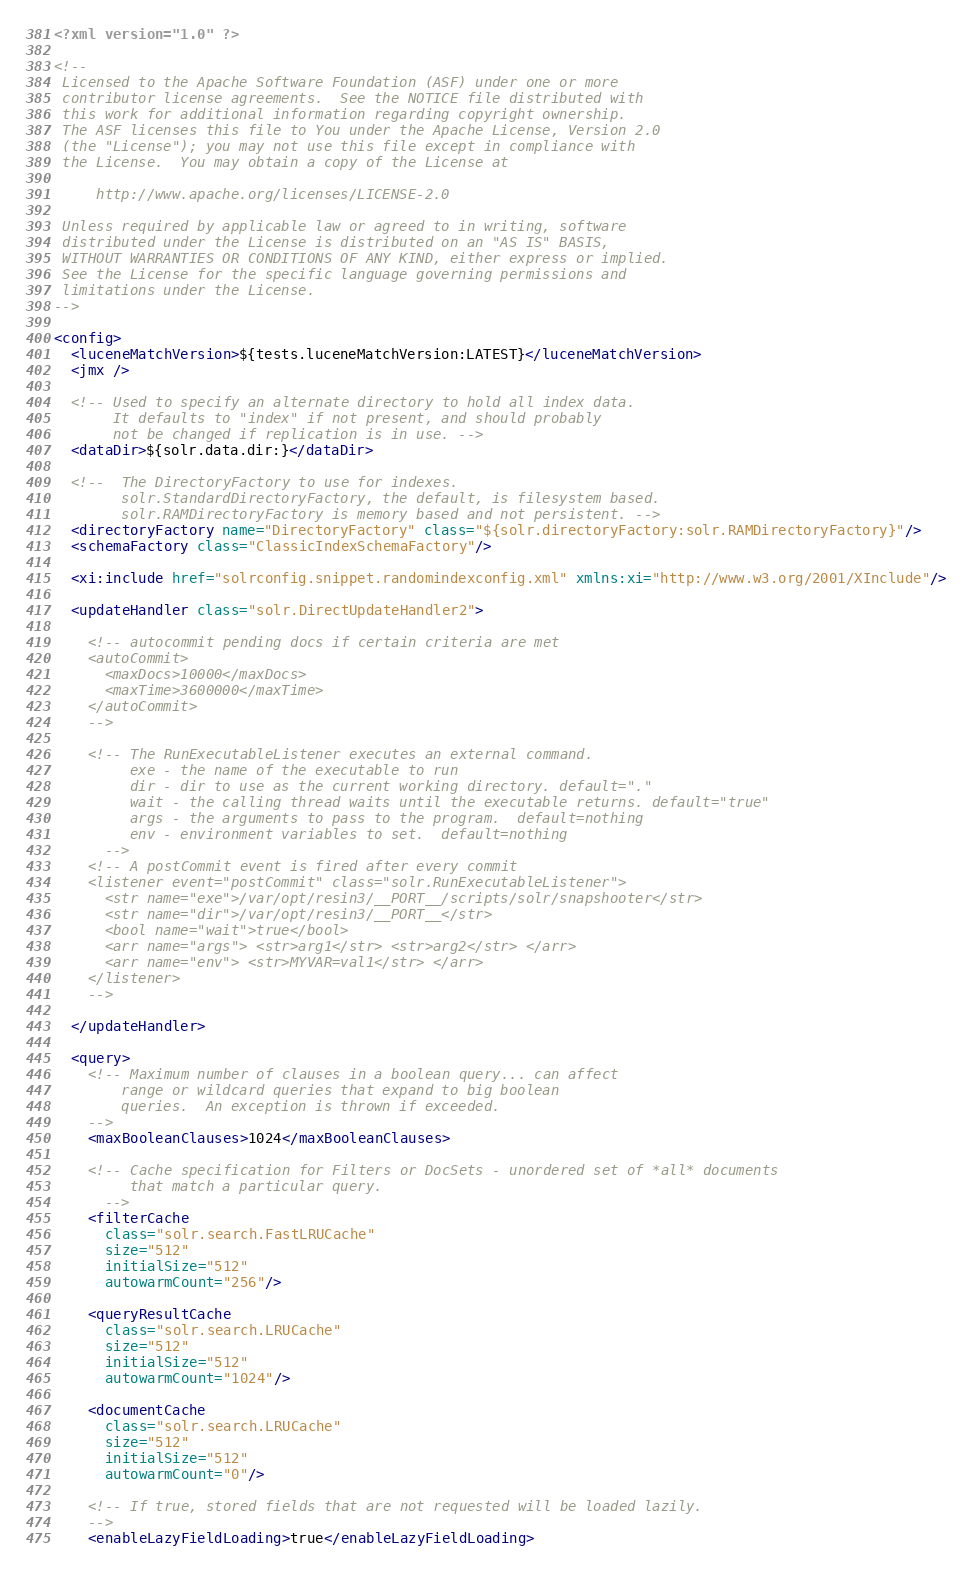Convert code to text. <code><loc_0><loc_0><loc_500><loc_500><_XML_><?xml version="1.0" ?>

<!--
 Licensed to the Apache Software Foundation (ASF) under one or more
 contributor license agreements.  See the NOTICE file distributed with
 this work for additional information regarding copyright ownership.
 The ASF licenses this file to You under the Apache License, Version 2.0
 (the "License"); you may not use this file except in compliance with
 the License.  You may obtain a copy of the License at

     http://www.apache.org/licenses/LICENSE-2.0

 Unless required by applicable law or agreed to in writing, software
 distributed under the License is distributed on an "AS IS" BASIS,
 WITHOUT WARRANTIES OR CONDITIONS OF ANY KIND, either express or implied.
 See the License for the specific language governing permissions and
 limitations under the License.
-->

<config>
  <luceneMatchVersion>${tests.luceneMatchVersion:LATEST}</luceneMatchVersion>
  <jmx />

  <!-- Used to specify an alternate directory to hold all index data.
       It defaults to "index" if not present, and should probably
       not be changed if replication is in use. -->
  <dataDir>${solr.data.dir:}</dataDir>

  <!--  The DirectoryFactory to use for indexes.
        solr.StandardDirectoryFactory, the default, is filesystem based.
        solr.RAMDirectoryFactory is memory based and not persistent. -->
  <directoryFactory name="DirectoryFactory" class="${solr.directoryFactory:solr.RAMDirectoryFactory}"/>
  <schemaFactory class="ClassicIndexSchemaFactory"/>

  <xi:include href="solrconfig.snippet.randomindexconfig.xml" xmlns:xi="http://www.w3.org/2001/XInclude"/>

  <updateHandler class="solr.DirectUpdateHandler2">

    <!-- autocommit pending docs if certain criteria are met 
    <autoCommit> 
      <maxDocs>10000</maxDocs>
      <maxTime>3600000</maxTime> 
    </autoCommit>
    -->

    <!-- The RunExecutableListener executes an external command.
         exe - the name of the executable to run
         dir - dir to use as the current working directory. default="."
         wait - the calling thread waits until the executable returns. default="true"
         args - the arguments to pass to the program.  default=nothing
         env - environment variables to set.  default=nothing
      -->
    <!-- A postCommit event is fired after every commit
    <listener event="postCommit" class="solr.RunExecutableListener">
      <str name="exe">/var/opt/resin3/__PORT__/scripts/solr/snapshooter</str>
      <str name="dir">/var/opt/resin3/__PORT__</str>
      <bool name="wait">true</bool>
      <arr name="args"> <str>arg1</str> <str>arg2</str> </arr>
      <arr name="env"> <str>MYVAR=val1</str> </arr>
    </listener>
    -->

  </updateHandler>

  <query>
    <!-- Maximum number of clauses in a boolean query... can affect
        range or wildcard queries that expand to big boolean
        queries.  An exception is thrown if exceeded.
    -->
    <maxBooleanClauses>1024</maxBooleanClauses>

    <!-- Cache specification for Filters or DocSets - unordered set of *all* documents
         that match a particular query.
      -->
    <filterCache
      class="solr.search.FastLRUCache"
      size="512"
      initialSize="512"
      autowarmCount="256"/>

    <queryResultCache
      class="solr.search.LRUCache"
      size="512"
      initialSize="512"
      autowarmCount="1024"/>

    <documentCache
      class="solr.search.LRUCache"
      size="512"
      initialSize="512"
      autowarmCount="0"/>

    <!-- If true, stored fields that are not requested will be loaded lazily.
    -->
    <enableLazyFieldLoading>true</enableLazyFieldLoading>
</code> 